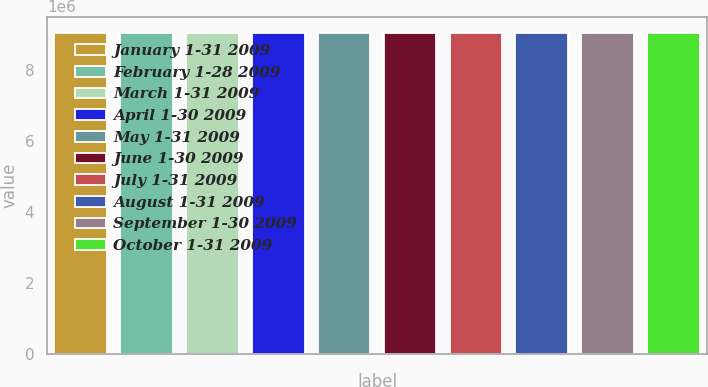Convert chart to OTSL. <chart><loc_0><loc_0><loc_500><loc_500><bar_chart><fcel>January 1-31 2009<fcel>February 1-28 2009<fcel>March 1-31 2009<fcel>April 1-30 2009<fcel>May 1-31 2009<fcel>June 1-30 2009<fcel>July 1-31 2009<fcel>August 1-31 2009<fcel>September 1-30 2009<fcel>October 1-31 2009<nl><fcel>9.04857e+06<fcel>9.04902e+06<fcel>9.04813e+06<fcel>9.0441e+06<fcel>9.04454e+06<fcel>9.04499e+06<fcel>9.04544e+06<fcel>9.04589e+06<fcel>9.04634e+06<fcel>9.04678e+06<nl></chart> 